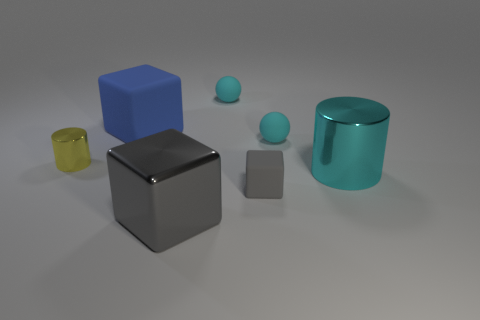How many cylinders are the same color as the metallic block?
Make the answer very short. 0. There is a shiny thing left of the large gray shiny block; is it the same shape as the big cyan metal object?
Offer a terse response. Yes. Are there fewer small yellow cylinders behind the blue cube than tiny cylinders that are on the left side of the yellow object?
Your answer should be compact. No. There is a gray object that is behind the large gray metallic block; what material is it?
Offer a very short reply. Rubber. What is the size of the object that is the same color as the small block?
Give a very brief answer. Large. Is there a rubber block of the same size as the yellow thing?
Your answer should be very brief. Yes. There is a small gray object; is it the same shape as the matte thing on the left side of the large gray metal thing?
Provide a succinct answer. Yes. There is a metallic thing that is in front of the big cyan metal cylinder; is its size the same as the matte block in front of the big blue rubber cube?
Make the answer very short. No. How many other things are the same shape as the tiny yellow metal thing?
Your answer should be compact. 1. What is the material of the big cube on the left side of the big object that is in front of the cyan shiny thing?
Make the answer very short. Rubber. 